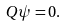Convert formula to latex. <formula><loc_0><loc_0><loc_500><loc_500>Q \psi = 0 .</formula> 